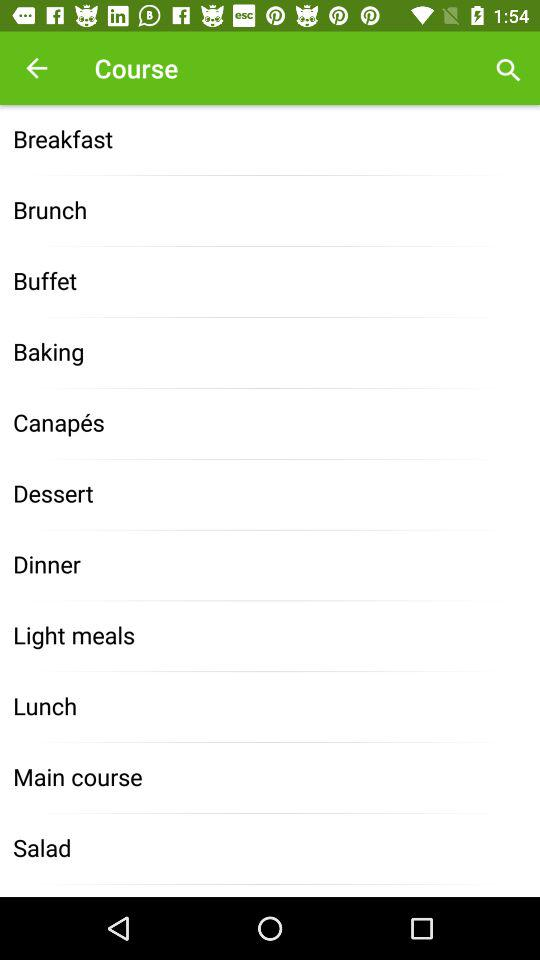What are the names of the courses? The names of the courses are "Breakfast", "Brunch", "Buffet", "Baking", "Canapés", "Dessert", "Dinner", "Light meals", "Lunch", "Main course" and "Salad". 